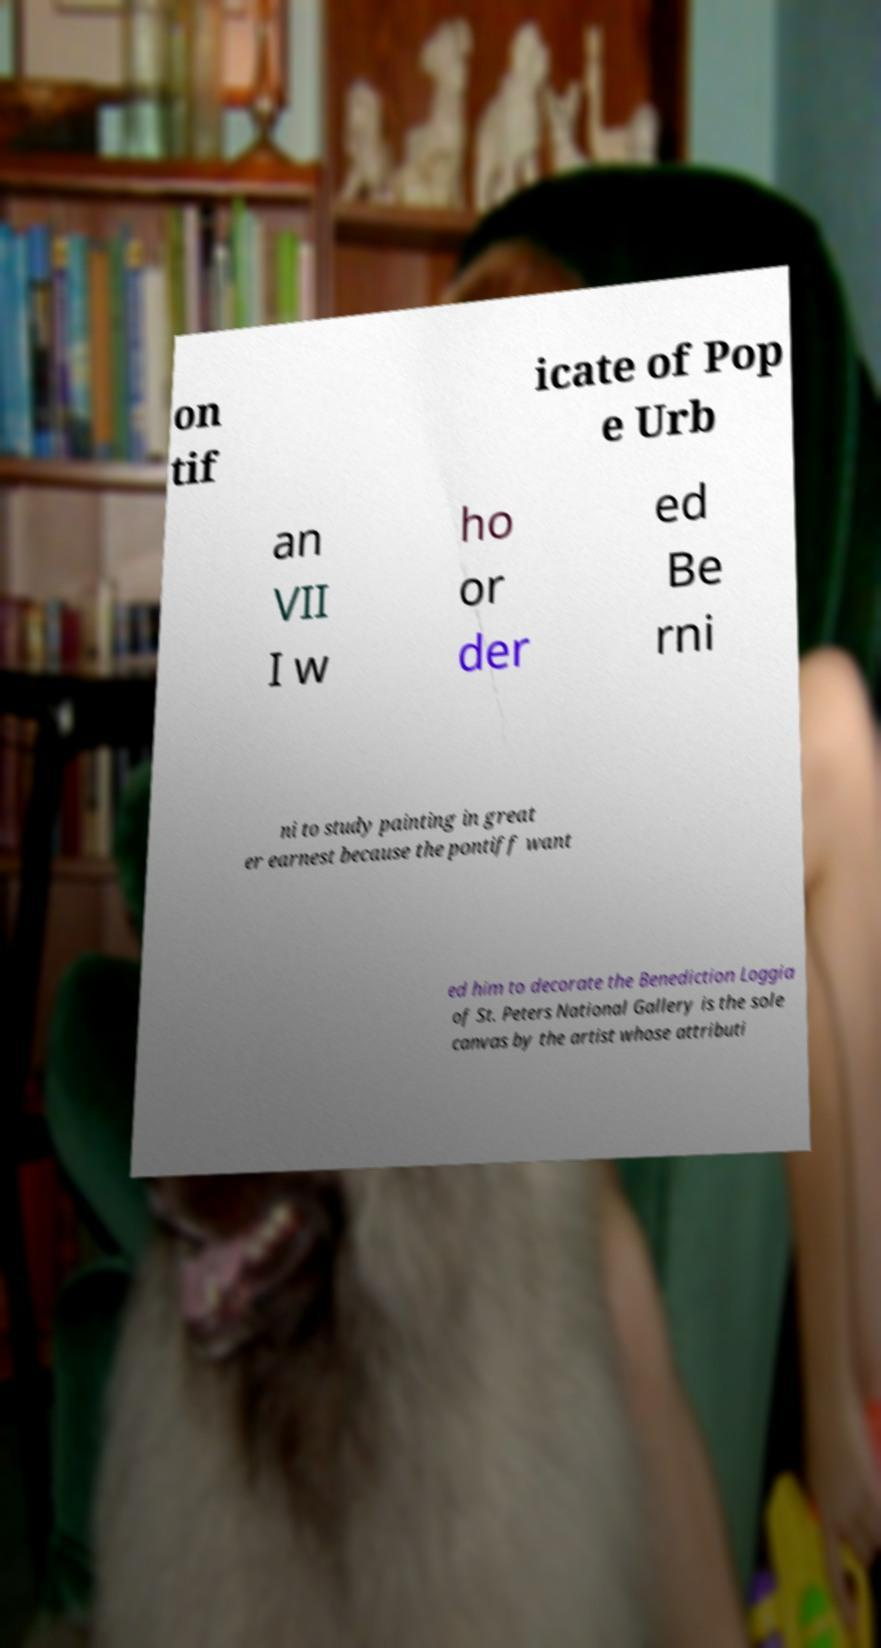Could you extract and type out the text from this image? on tif icate of Pop e Urb an VII I w ho or der ed Be rni ni to study painting in great er earnest because the pontiff want ed him to decorate the Benediction Loggia of St. Peters National Gallery is the sole canvas by the artist whose attributi 